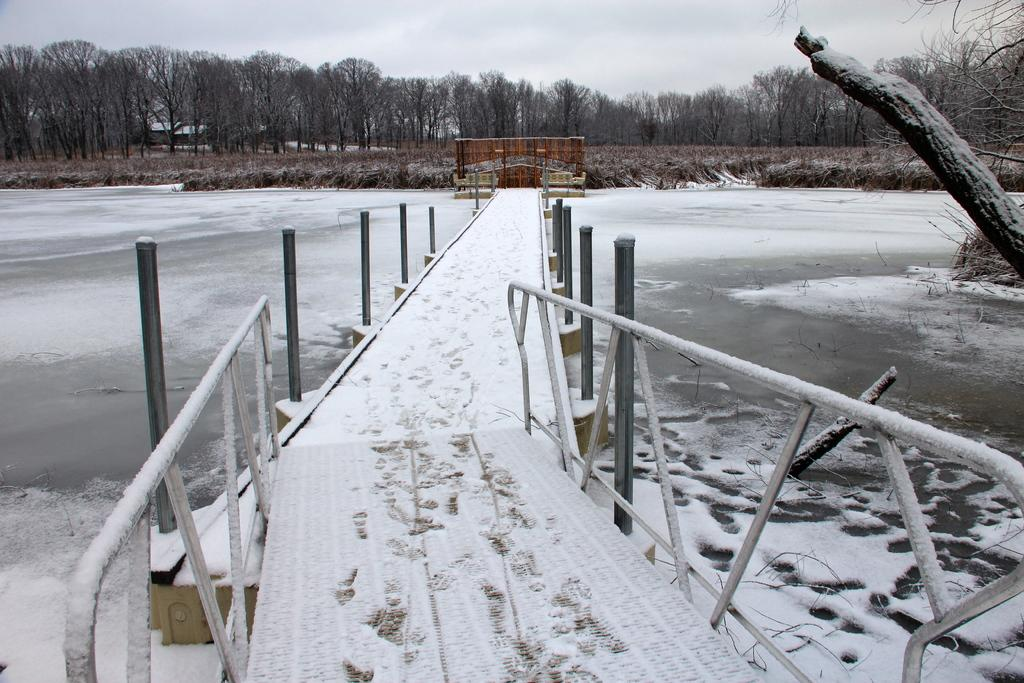What structure is present in the image? There is a bridge in the image. What is the bridge positioned over? The bridge is over a lake. How is the lake affected by the weather? The lake is covered with snow. What can be seen in the background of the image? There are trees and the sky visible in the background of the image. What color is the authority's finger in the image? There is no authority or finger present in the image. 